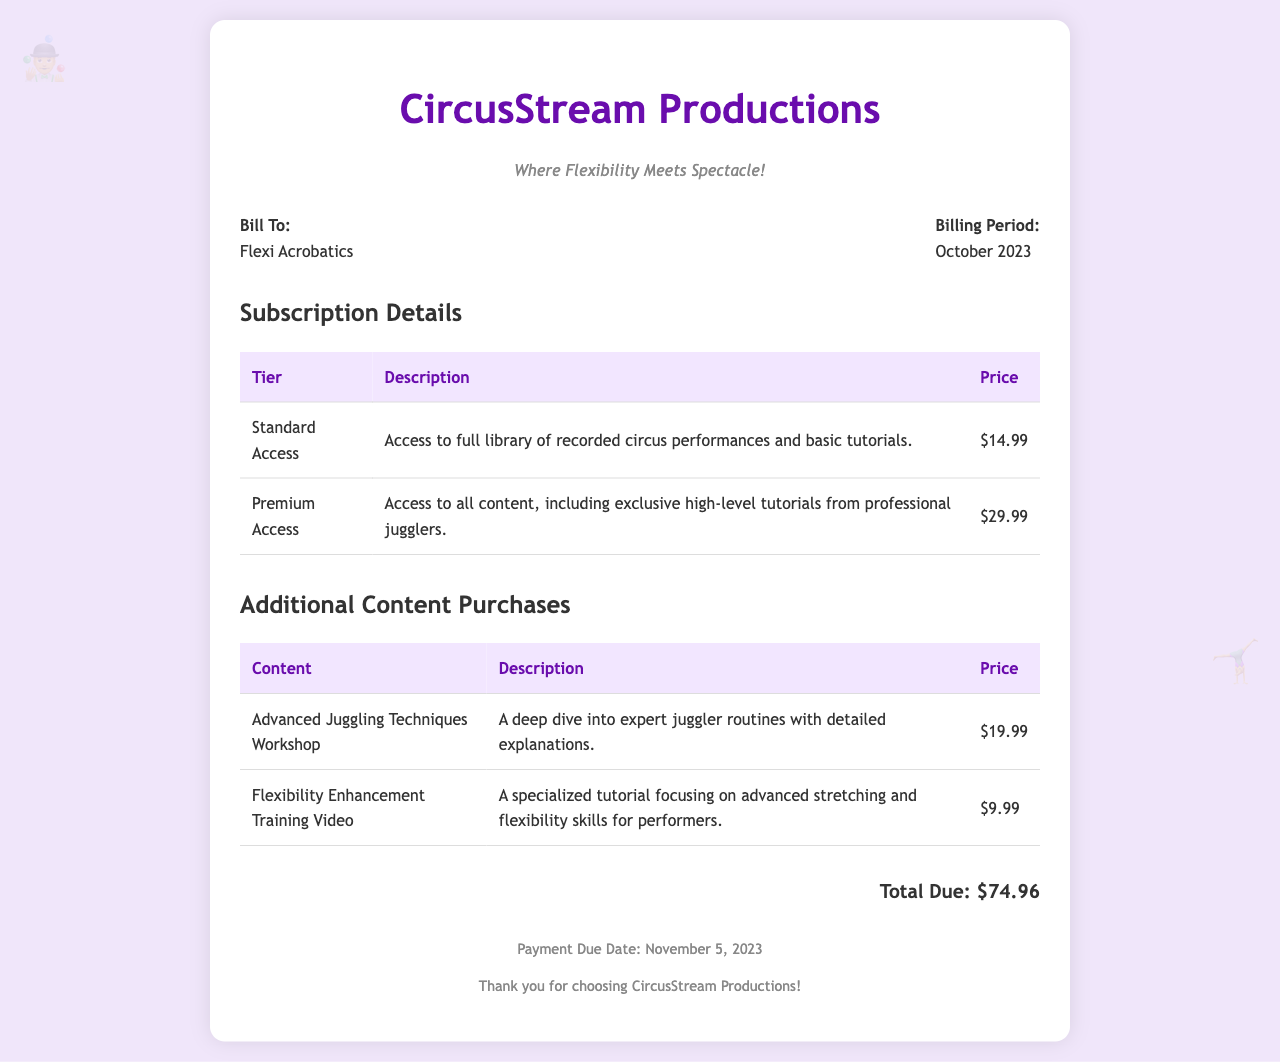What is the total due? The total due is the final amount listed at the bottom of the invoice, summarizing all charges.
Answer: $74.96 What is the billing period? The billing period is specified in the document, indicating the timeframe for which the services are being charged.
Answer: October 2023 Who is billed? The document includes the name of the entity to which the invoice is addressed.
Answer: Flexi Acrobatics How many subscription tiers are listed? The number of subscription tiers provided is reflected in the subscription details section of the document.
Answer: 2 What is included in Premium Access? This asks for a description found in the subscription details that explains the Premium Access tier's benefits.
Answer: Exclusive high-level tutorials from professional jugglers What is the price of the Advanced Juggling Techniques Workshop? This information can be found in the additional content purchases section regarding the pricing.
Answer: $19.99 What is the payment due date? The document specifies when the payment must be made, which is relevant for invoicing.
Answer: November 5, 2023 What type of service is being billed? This question relates to the overall nature of the invoice, which is clear in its purpose.
Answer: Streaming service 